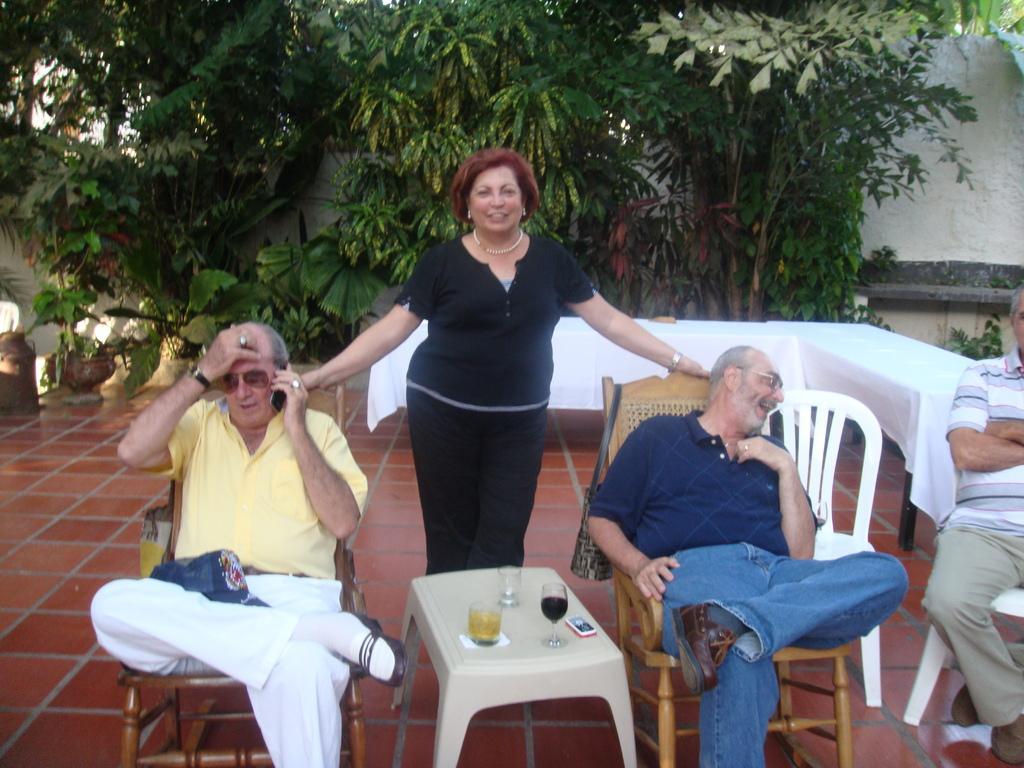In one or two sentences, can you explain what this image depicts? In this image there are four people on the left side there is one man sitting and talking in phone. On the right side there is another man sitting and smiling. On the right side there is one man who is sitting and on the middle of the image there is one woman standing and smiling, and on the background there are some plants and trees and some flower pots. In the middle of the image there is one table and some glasses on it and the glasses contains some drink. And one mobile is on the table on the right side there is one table and on the top of the right corner there is one wall. 